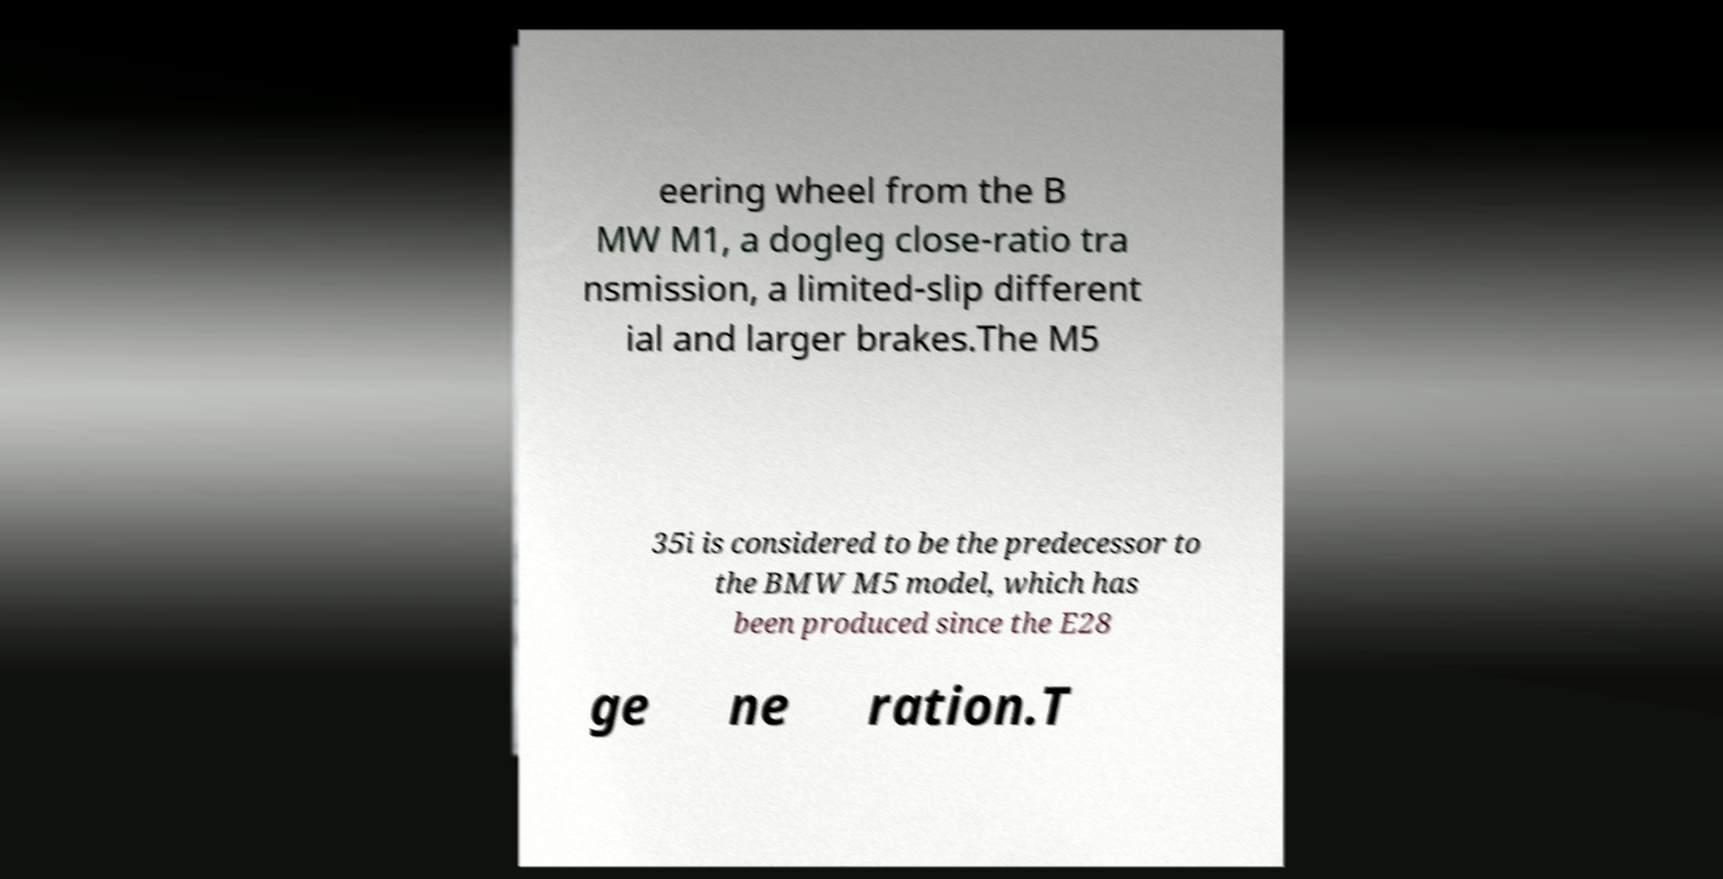Could you extract and type out the text from this image? eering wheel from the B MW M1, a dogleg close-ratio tra nsmission, a limited-slip different ial and larger brakes.The M5 35i is considered to be the predecessor to the BMW M5 model, which has been produced since the E28 ge ne ration.T 